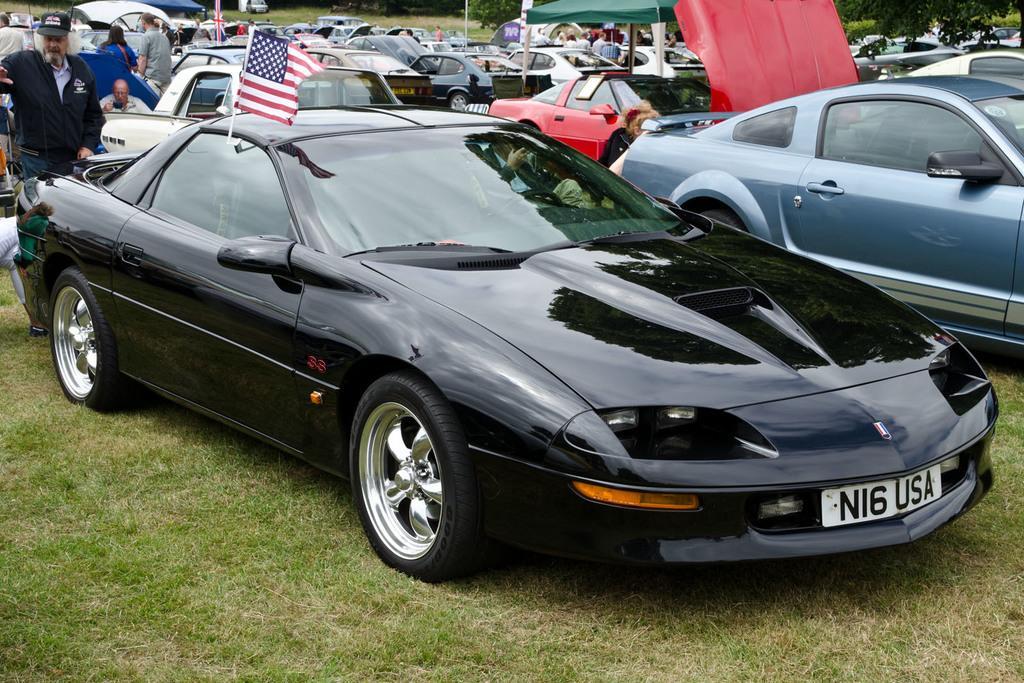Can you describe this image briefly? In this picture I can observe some cars parked in the parking lot in the middle of the picture. On the left side I can observe few people. There is some grass on the ground. 